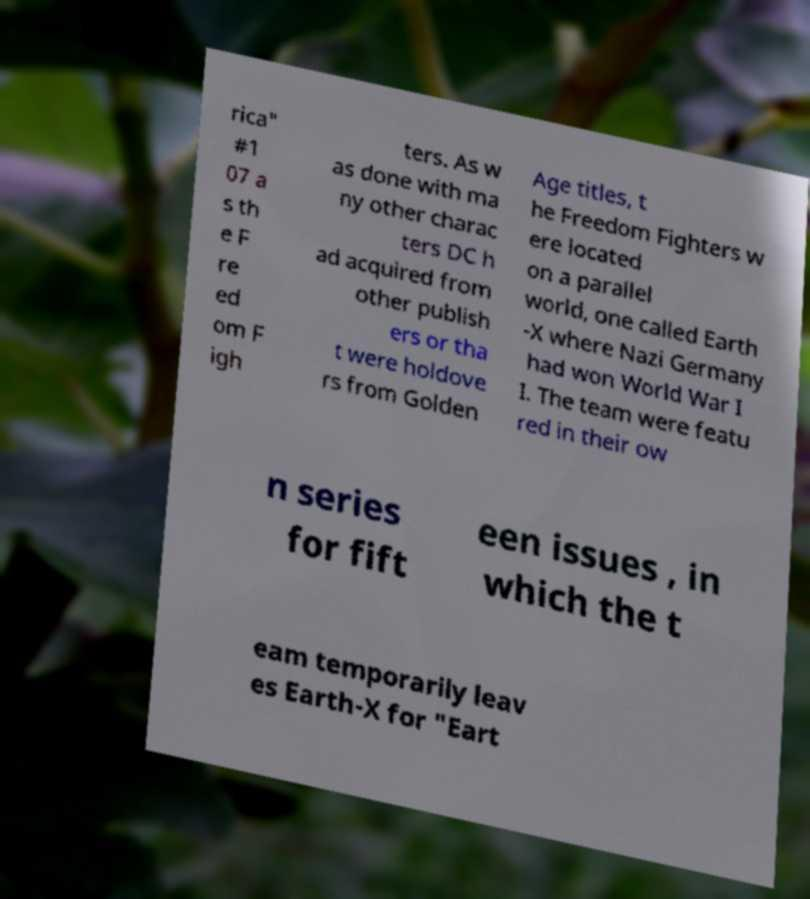Could you assist in decoding the text presented in this image and type it out clearly? rica" #1 07 a s th e F re ed om F igh ters. As w as done with ma ny other charac ters DC h ad acquired from other publish ers or tha t were holdove rs from Golden Age titles, t he Freedom Fighters w ere located on a parallel world, one called Earth -X where Nazi Germany had won World War I I. The team were featu red in their ow n series for fift een issues , in which the t eam temporarily leav es Earth-X for "Eart 